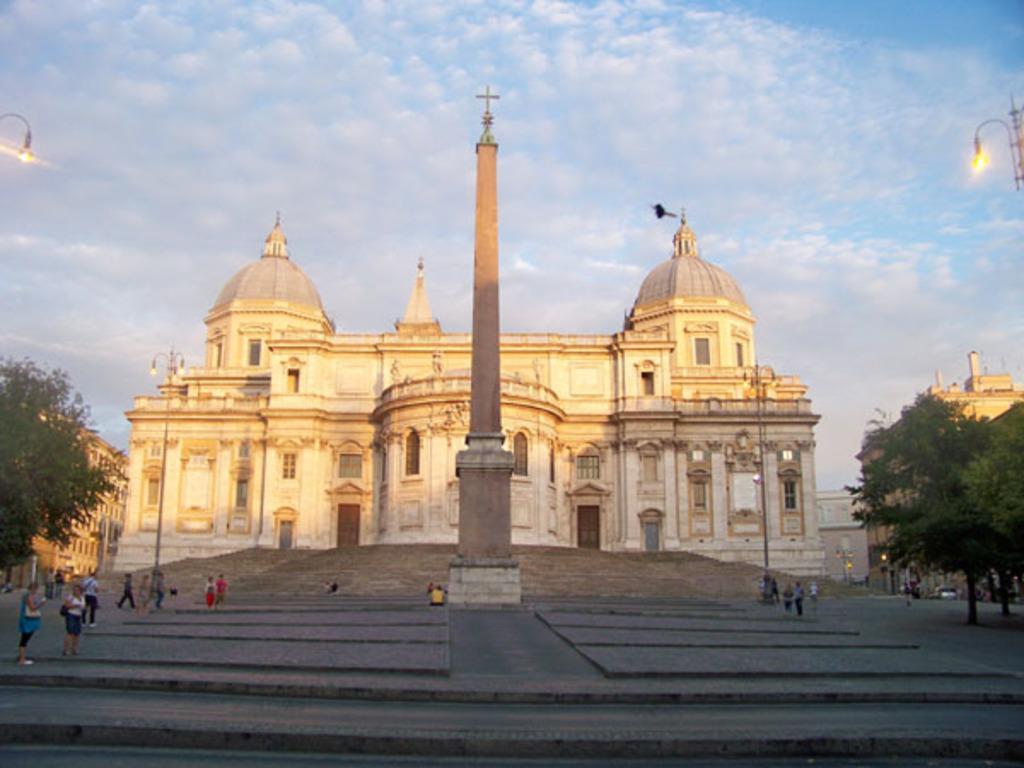Could you give a brief overview of what you see in this image? This image is taken outdoors. At the top of the image there is a sky with clouds. At the bottom of the image there is a floor and there are a few stairs. In the middle of the image there is a pillar with a cross symbol and there is a Cathedral with walls, windows, carvings, doors and a roof. A few people are walking and a few are standing. On the left and right sides of the image there are two street lights, a few buildings and trees. A few cars are parked on the road. 